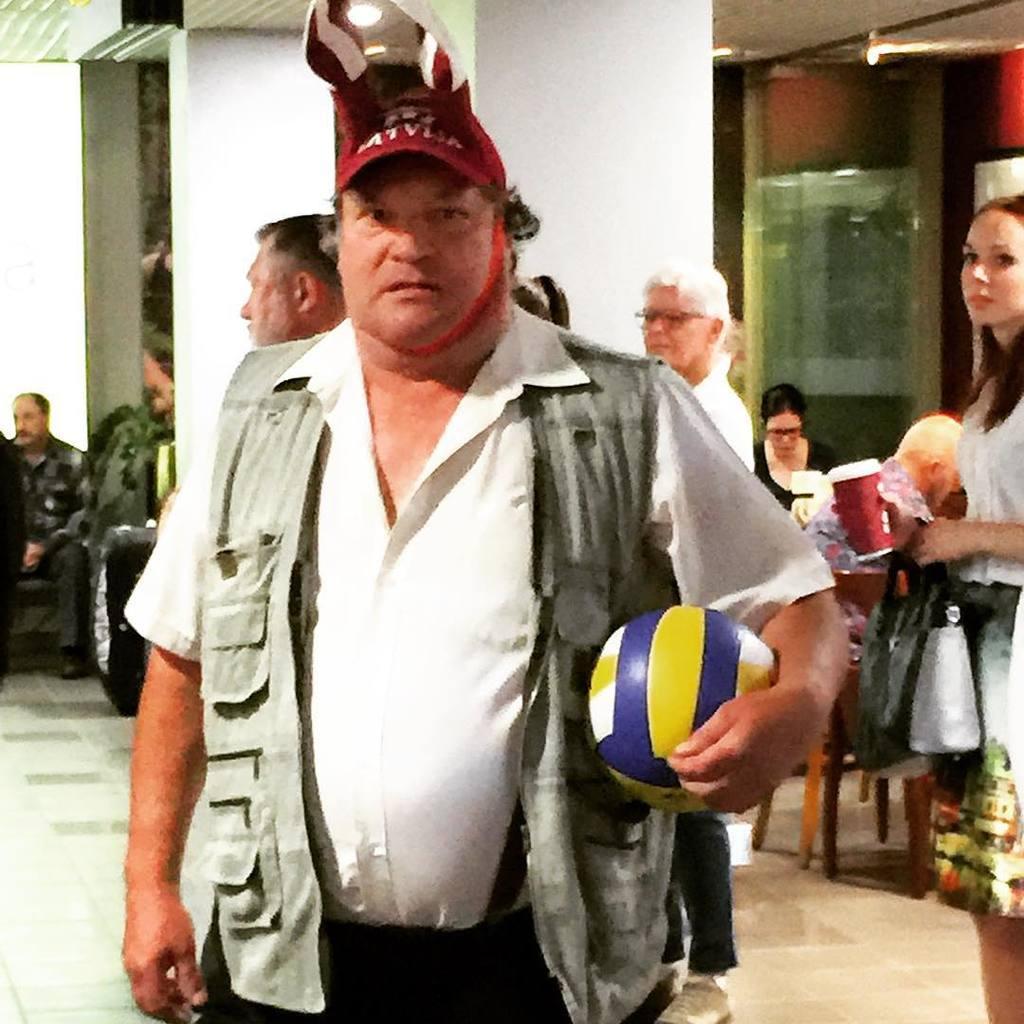Describe this image in one or two sentences. In this picture there is a man standing, holding a ball in his hand. He is wearing a cap on his head. In the background there are some people standing and sitting in the chair. We can observe pillar here. 